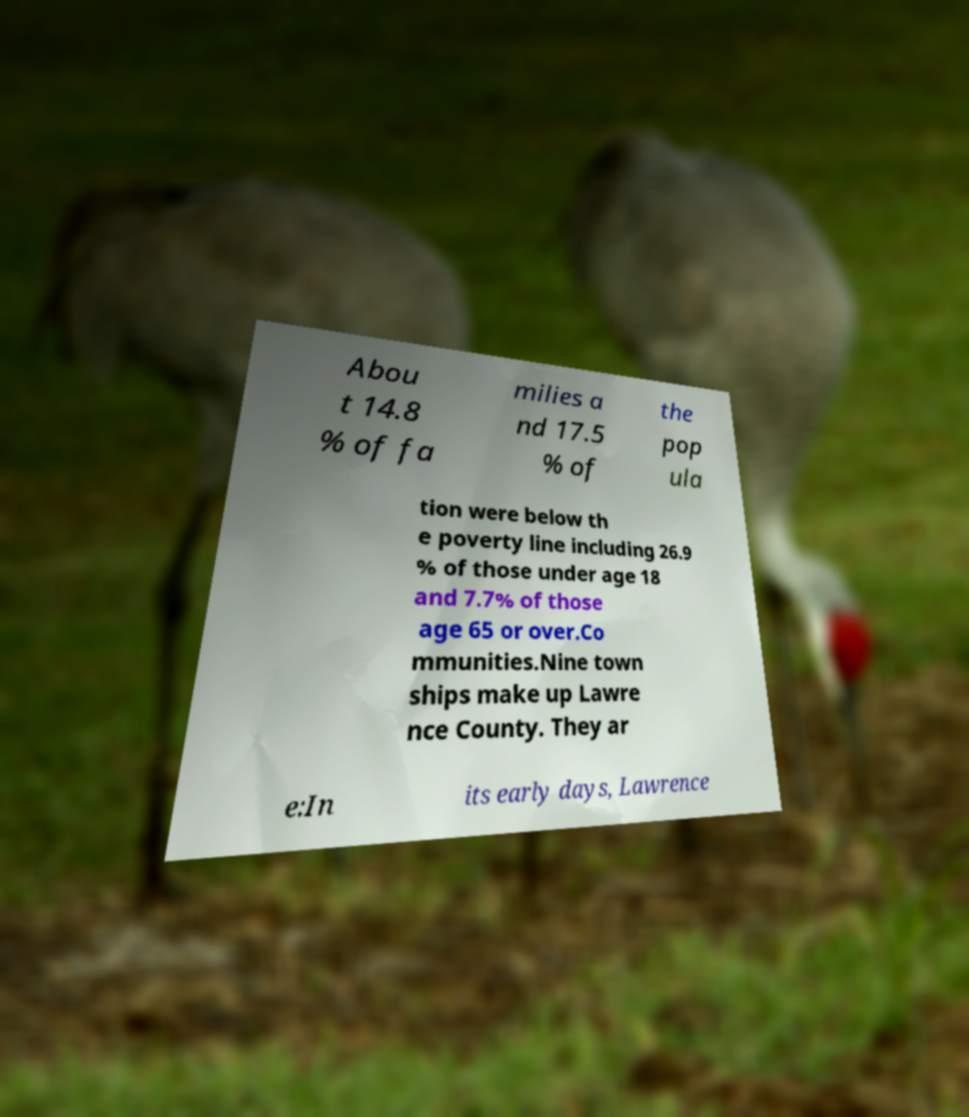I need the written content from this picture converted into text. Can you do that? Abou t 14.8 % of fa milies a nd 17.5 % of the pop ula tion were below th e poverty line including 26.9 % of those under age 18 and 7.7% of those age 65 or over.Co mmunities.Nine town ships make up Lawre nce County. They ar e:In its early days, Lawrence 